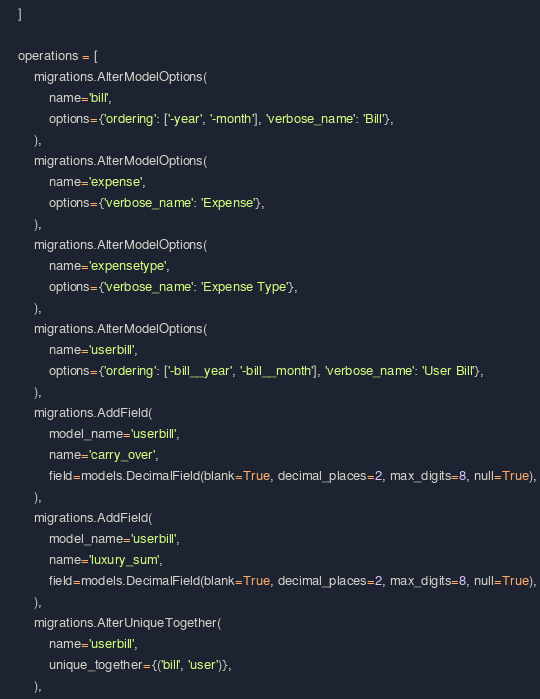Convert code to text. <code><loc_0><loc_0><loc_500><loc_500><_Python_>    ]

    operations = [
        migrations.AlterModelOptions(
            name='bill',
            options={'ordering': ['-year', '-month'], 'verbose_name': 'Bill'},
        ),
        migrations.AlterModelOptions(
            name='expense',
            options={'verbose_name': 'Expense'},
        ),
        migrations.AlterModelOptions(
            name='expensetype',
            options={'verbose_name': 'Expense Type'},
        ),
        migrations.AlterModelOptions(
            name='userbill',
            options={'ordering': ['-bill__year', '-bill__month'], 'verbose_name': 'User Bill'},
        ),
        migrations.AddField(
            model_name='userbill',
            name='carry_over',
            field=models.DecimalField(blank=True, decimal_places=2, max_digits=8, null=True),
        ),
        migrations.AddField(
            model_name='userbill',
            name='luxury_sum',
            field=models.DecimalField(blank=True, decimal_places=2, max_digits=8, null=True),
        ),
        migrations.AlterUniqueTogether(
            name='userbill',
            unique_together={('bill', 'user')},
        ),</code> 